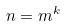Convert formula to latex. <formula><loc_0><loc_0><loc_500><loc_500>n = m ^ { k }</formula> 